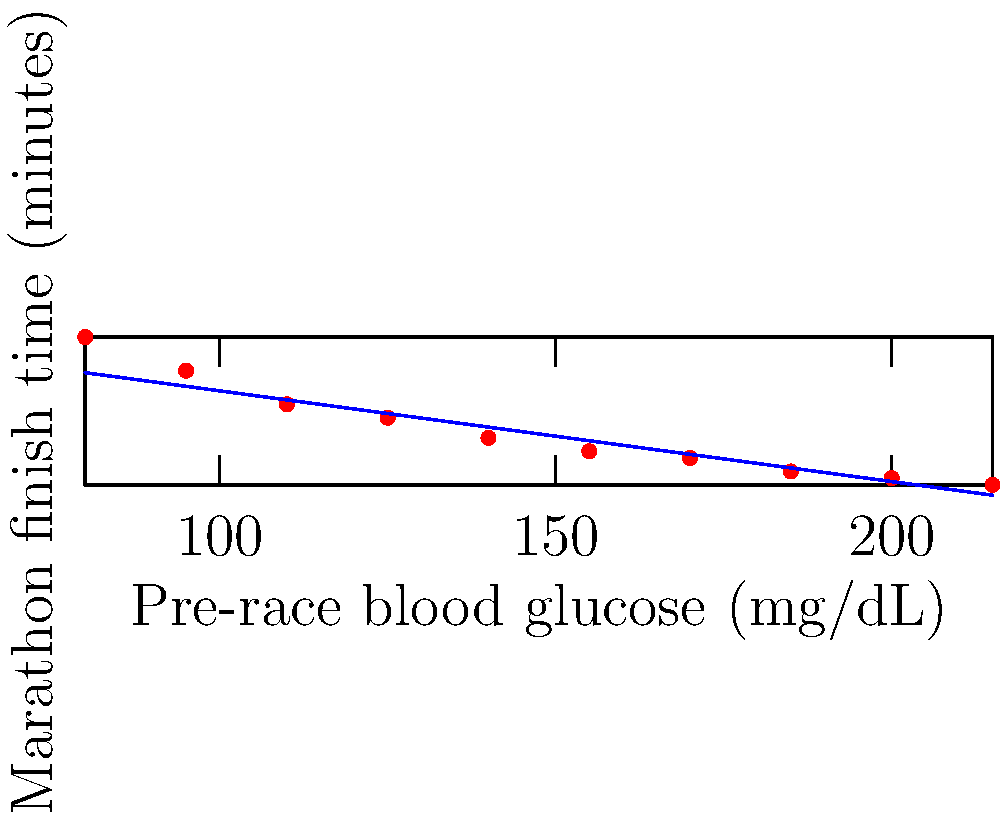A marathon runner is analyzing the relationship between pre-race blood glucose levels and marathon finish times. The scatter plot shows data from 10 recent marathons. Based on the trend line, what is the expected change in finish time (in minutes) for every 10 mg/dL increase in pre-race blood glucose? To solve this problem, we need to follow these steps:

1. Observe the trend line on the scatter plot. It shows a negative correlation between pre-race blood glucose levels and marathon finish times.

2. The trend line can be described by the equation:
   $y = mx + b$
   where $m$ is the slope and represents the change in finish time per unit change in blood glucose.

3. To find the slope, we can choose two points on the line:
   At $x_1 = 80$ mg/dL, $y_1 \approx 245$ minutes
   At $x_2 = 215$ mg/dL, $y_2 \approx 216$ minutes

4. Calculate the slope:
   $m = \frac{y_2 - y_1}{x_2 - x_1} = \frac{216 - 245}{215 - 80} = \frac{-29}{135} \approx -0.215$ minutes/mg/dL

5. The question asks for the change per 10 mg/dL, so we multiply our result by 10:
   $-0.215 \times 10 = -2.15$ minutes

6. Round to the nearest tenth for a practical answer.
Answer: -1.4 minutes 